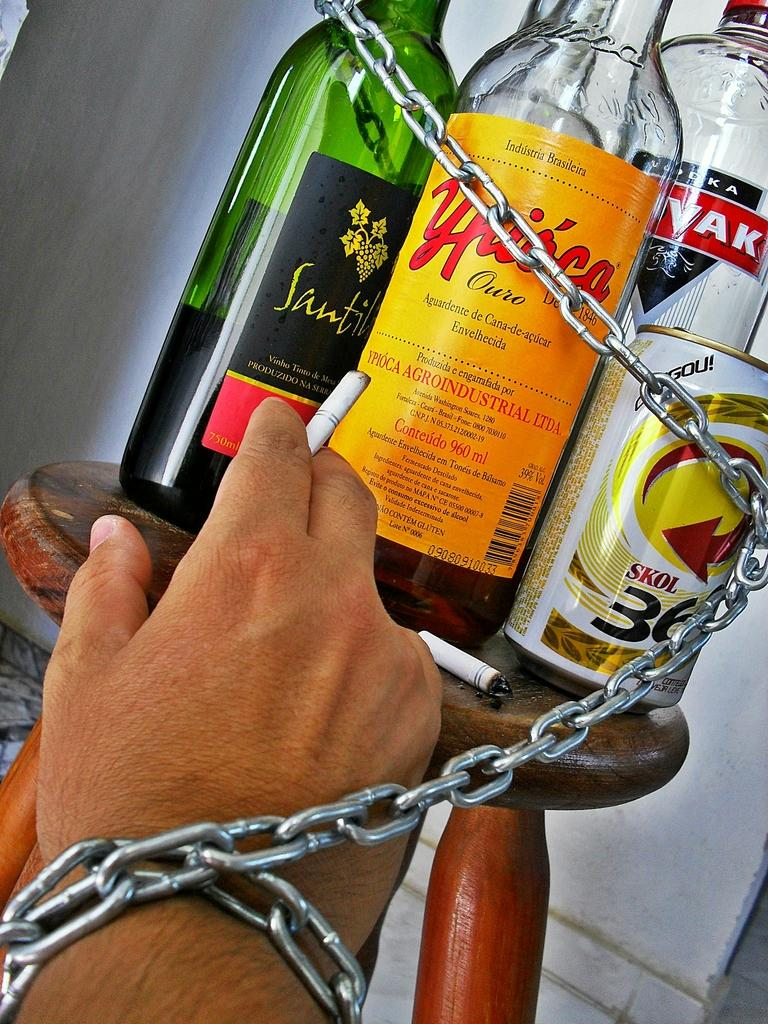What object is present on the small stool in the image? There is a cigar and bottles on the stool in the image. What is the cigar being used for in the image? The cigar is being held by a hand in the image. What is the hand holding in addition to the cigar? The hand is holding a chain. Where are the bottles located in relation to the cigar? The bottles are on the stool along with the cigar. How many frogs are sitting on the cup in the image? There is no cup or frogs present in the image. Is there a camera visible in the image? There is no camera present in the image. 